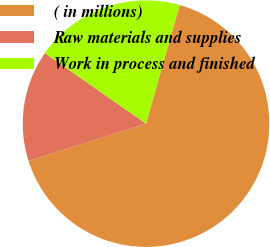Convert chart to OTSL. <chart><loc_0><loc_0><loc_500><loc_500><pie_chart><fcel>( in millions)<fcel>Raw materials and supplies<fcel>Work in process and finished<nl><fcel>65.7%<fcel>14.59%<fcel>19.7%<nl></chart> 